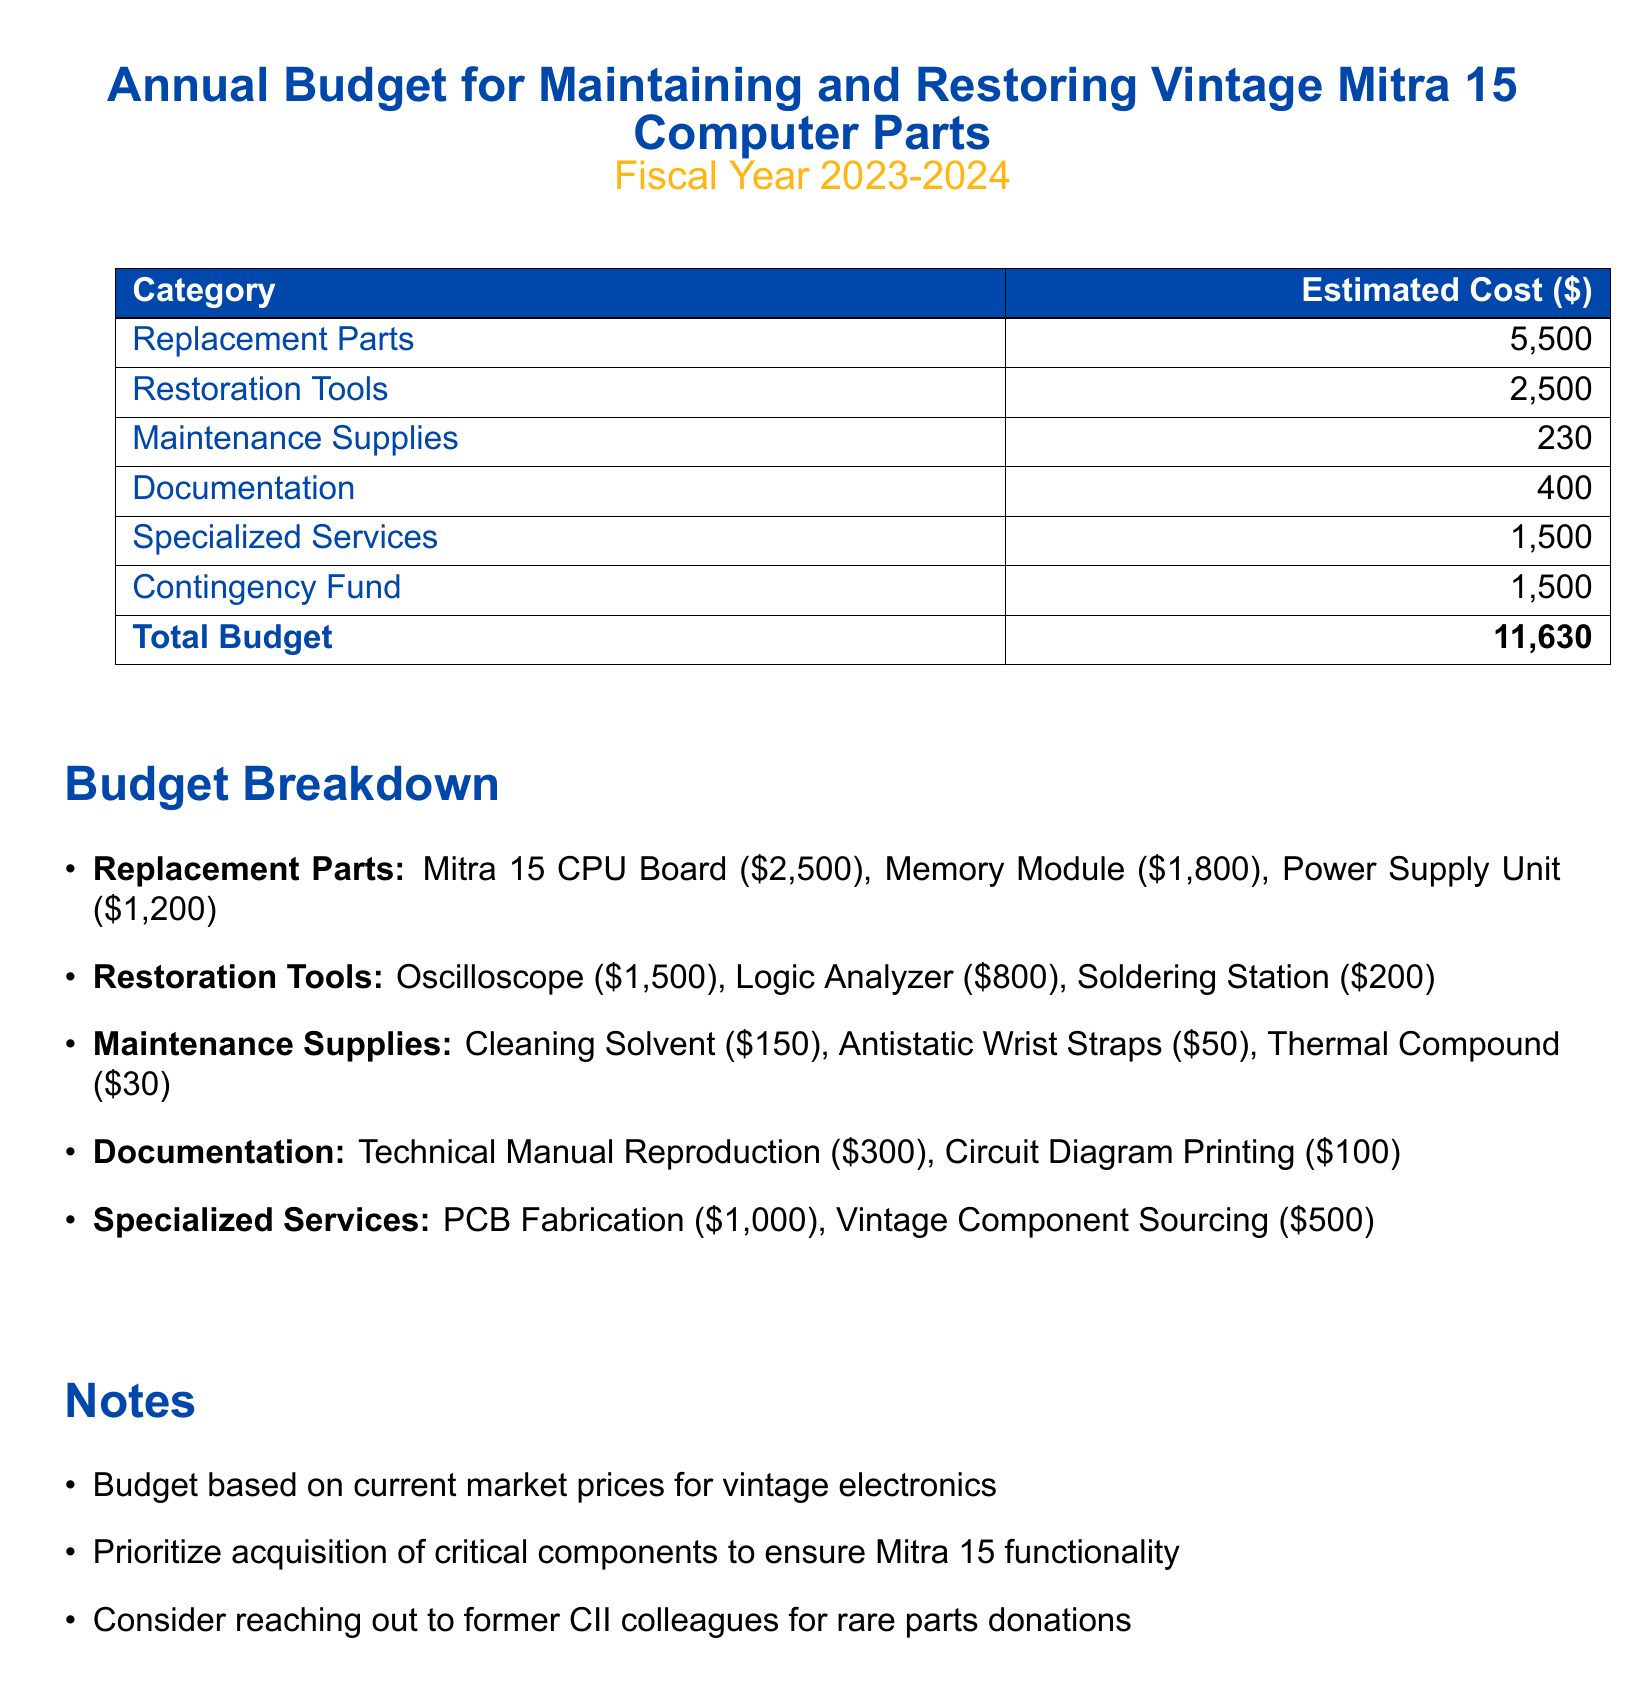what is the total budget? The total budget is provided in the document, totaling all the estimated costs, which amounts to $11,630.
Answer: $11,630 how much is allocated for replacement parts? The document explicitly lists the estimated cost for replacement parts, which is $5,500.
Answer: $5,500 what is the cost of a logic analyzer? The document outlines the cost of the logic analyzer under restoration tools, which is $800.
Answer: $800 what is included in maintenance supplies? The budget breakdown lists specific items included in maintenance supplies, which are cleaning solvent, antistatic wrist straps, and thermal compound.
Answer: Cleaning solvent, antistatic wrist straps, thermal compound what is the estimated cost for documentation? The document specifies the estimated cost for documentation, which is $400.
Answer: $400 how much is earmarked for specialized services? The document specifies the budget for specialized services amounts to $1,500.
Answer: $1,500 what is the purpose of the contingency fund? The document notes that the contingency fund is set aside to cover unexpected expenses or issues that may arise during the maintenance and restoration process of the Mitra 15.
Answer: Cover unexpected expenses how much is allocated for the oscilloscope? The cost of the oscilloscope is specified in the restoration tools section of the budget, which is $1,500.
Answer: $1,500 what items are prioritized for acquisition according to the notes? The notes in the document emphasize the priority for acquiring critical components to ensure the functionality of the Mitra 15.
Answer: Critical components 